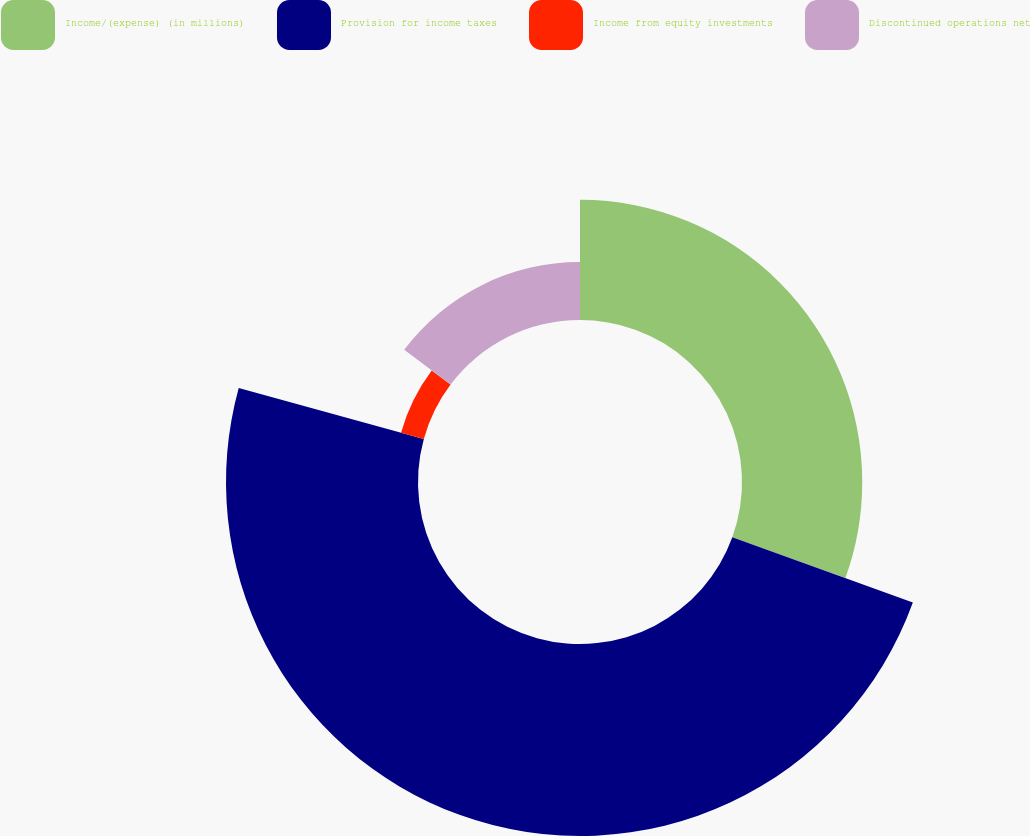Convert chart to OTSL. <chart><loc_0><loc_0><loc_500><loc_500><pie_chart><fcel>Income/(expense) (in millions)<fcel>Provision for income taxes<fcel>Income from equity investments<fcel>Discontinued operations net<nl><fcel>30.53%<fcel>48.75%<fcel>5.99%<fcel>14.73%<nl></chart> 